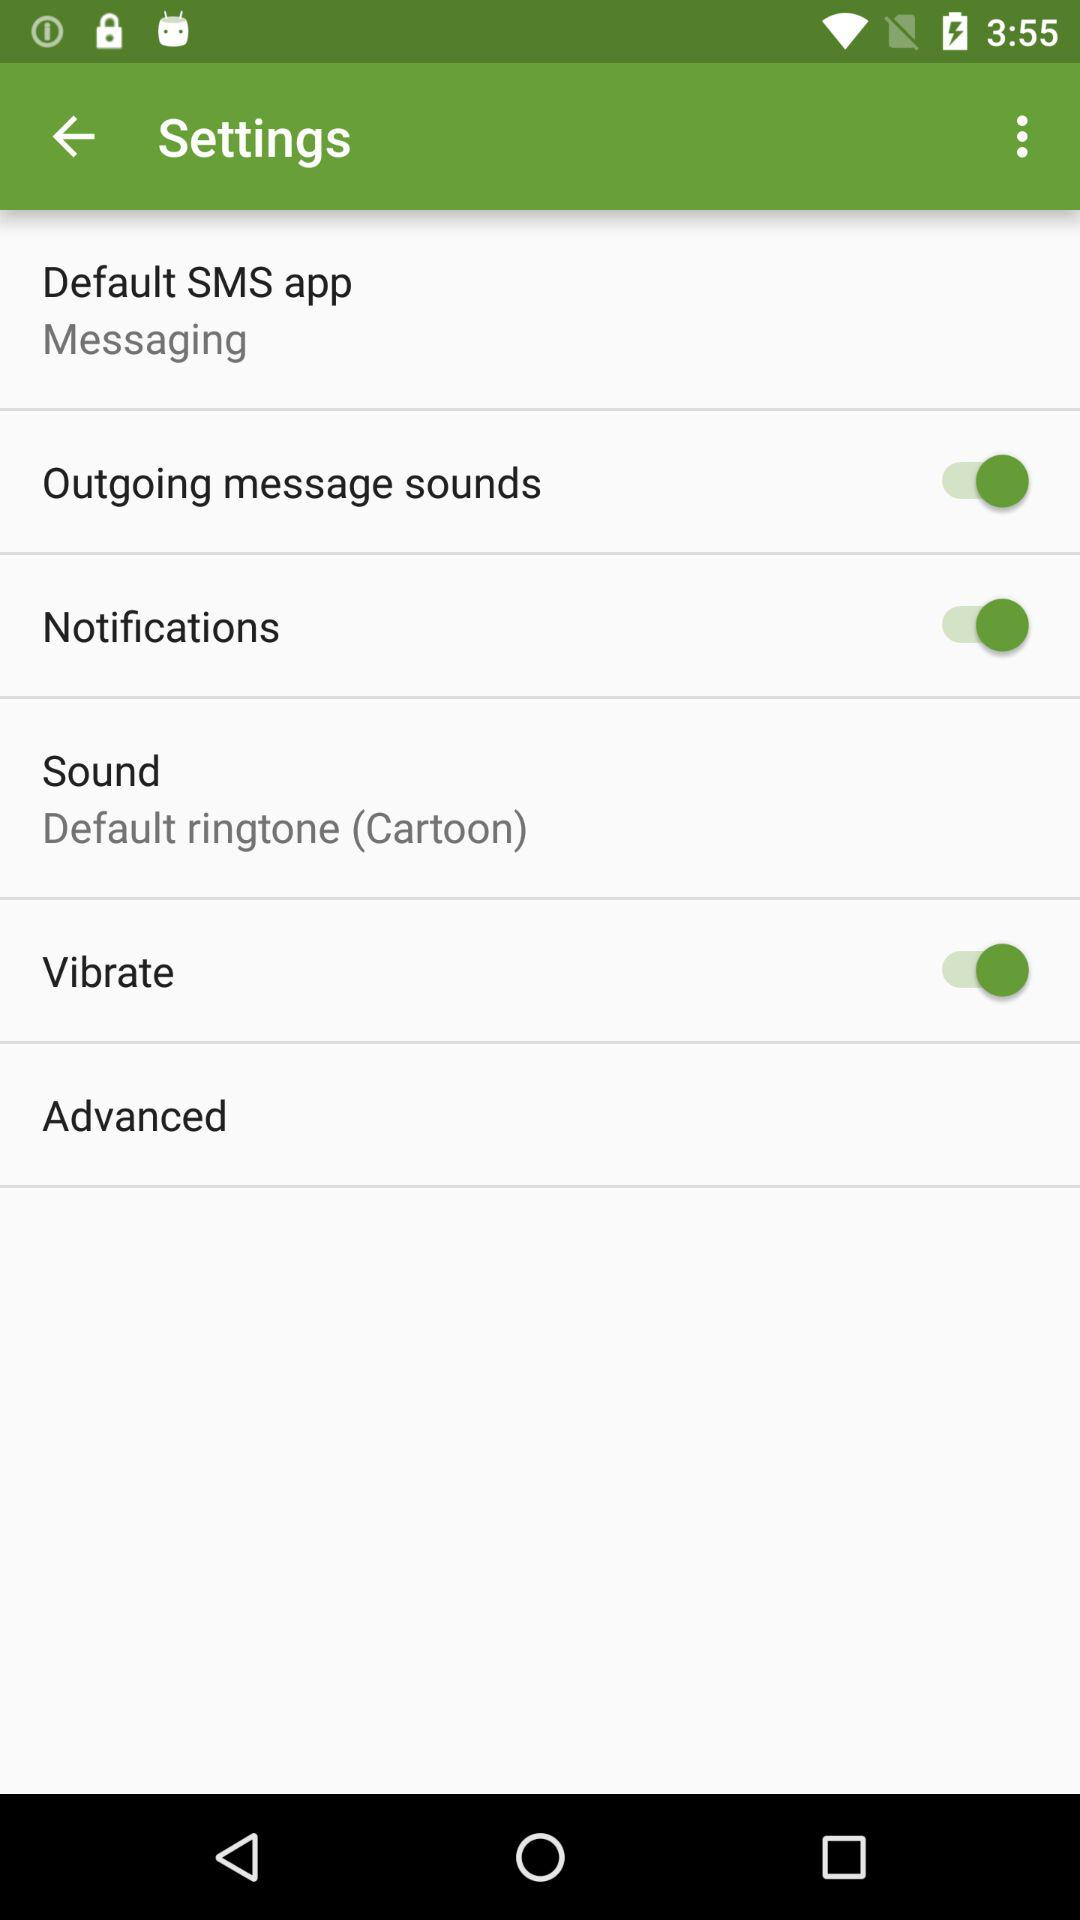What is the selected sound? The selected sound is "Default ringtone (Cartoon)". 